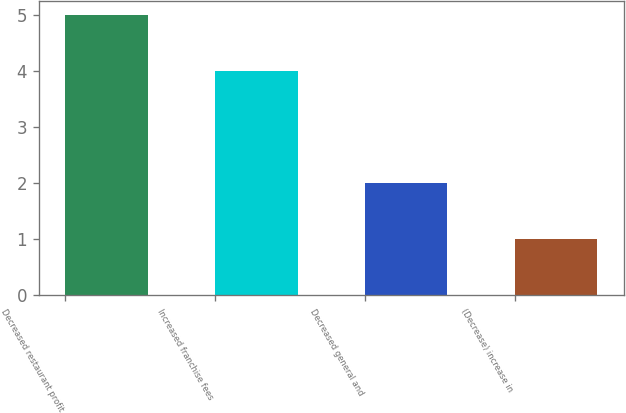Convert chart. <chart><loc_0><loc_0><loc_500><loc_500><bar_chart><fcel>Decreased restaurant profit<fcel>Increased franchise fees<fcel>Decreased general and<fcel>(Decrease) increase in<nl><fcel>5<fcel>4<fcel>2<fcel>1<nl></chart> 